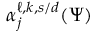Convert formula to latex. <formula><loc_0><loc_0><loc_500><loc_500>\alpha _ { j } ^ { \ell , k , s / d } ( \Psi )</formula> 